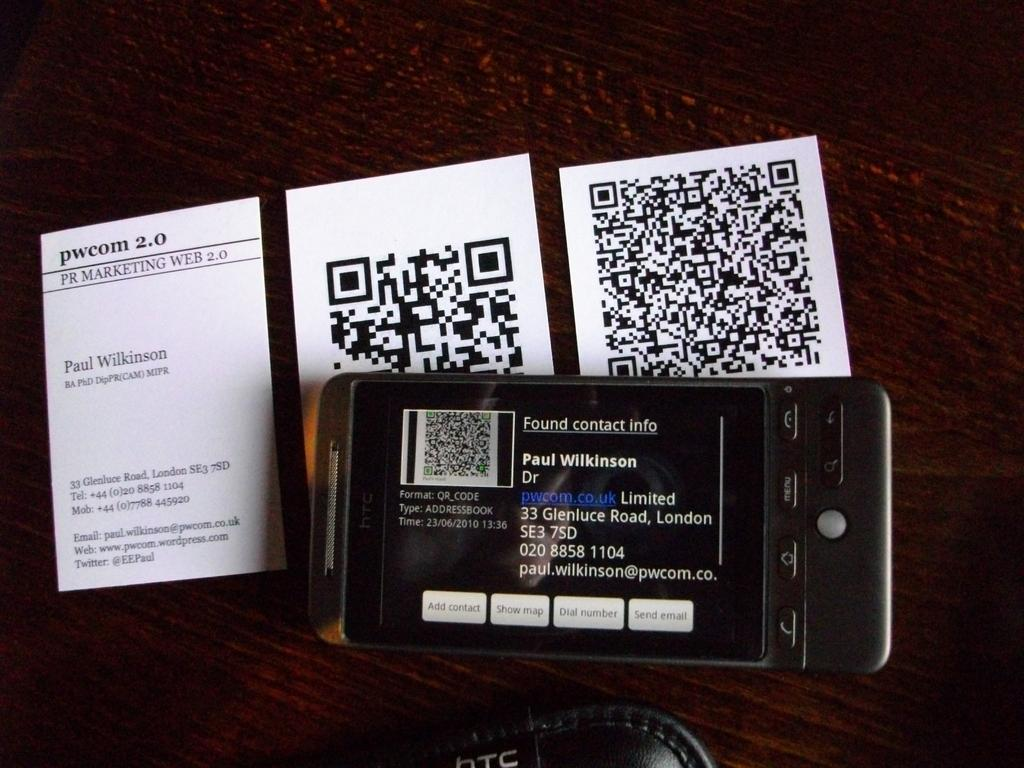Provide a one-sentence caption for the provided image. a phone on its side with the name Paul Wilkinson on it. 